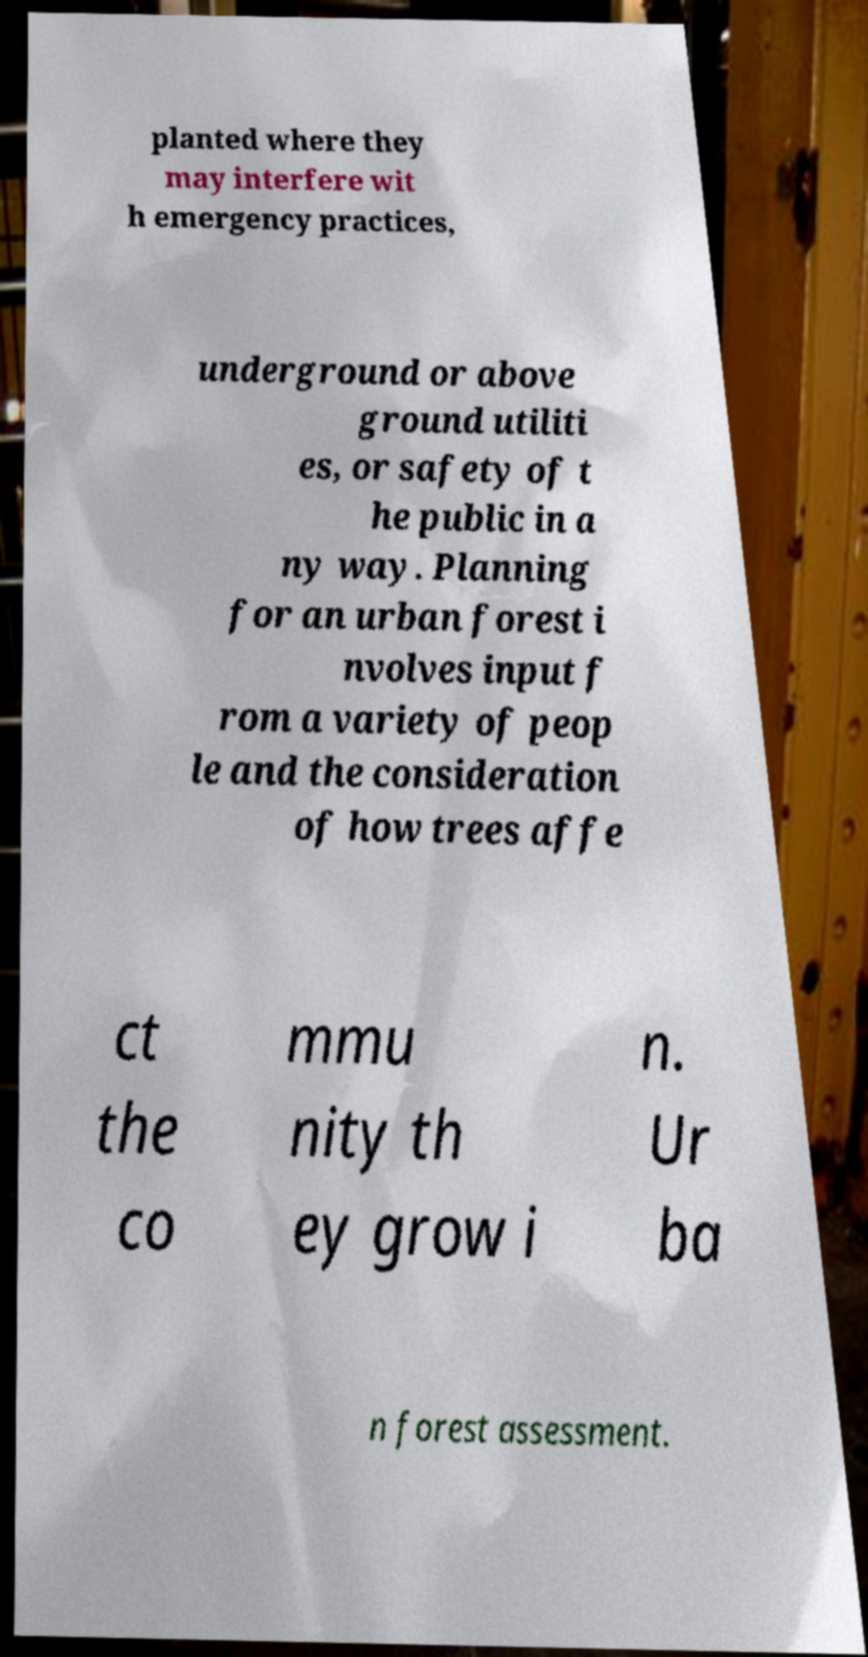Could you assist in decoding the text presented in this image and type it out clearly? planted where they may interfere wit h emergency practices, underground or above ground utiliti es, or safety of t he public in a ny way. Planning for an urban forest i nvolves input f rom a variety of peop le and the consideration of how trees affe ct the co mmu nity th ey grow i n. Ur ba n forest assessment. 